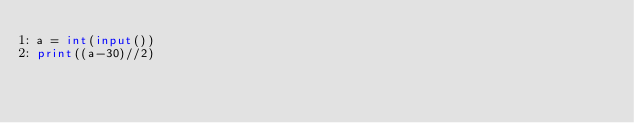Convert code to text. <code><loc_0><loc_0><loc_500><loc_500><_Python_>a = int(input())
print((a-30)//2)
</code> 